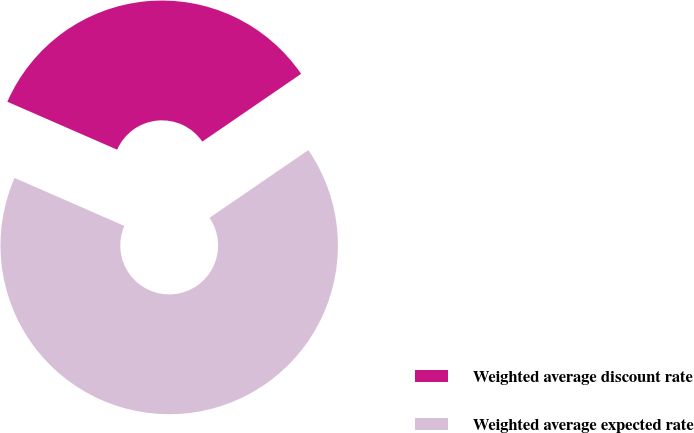Convert chart. <chart><loc_0><loc_0><loc_500><loc_500><pie_chart><fcel>Weighted average discount rate<fcel>Weighted average expected rate<nl><fcel>33.88%<fcel>66.12%<nl></chart> 